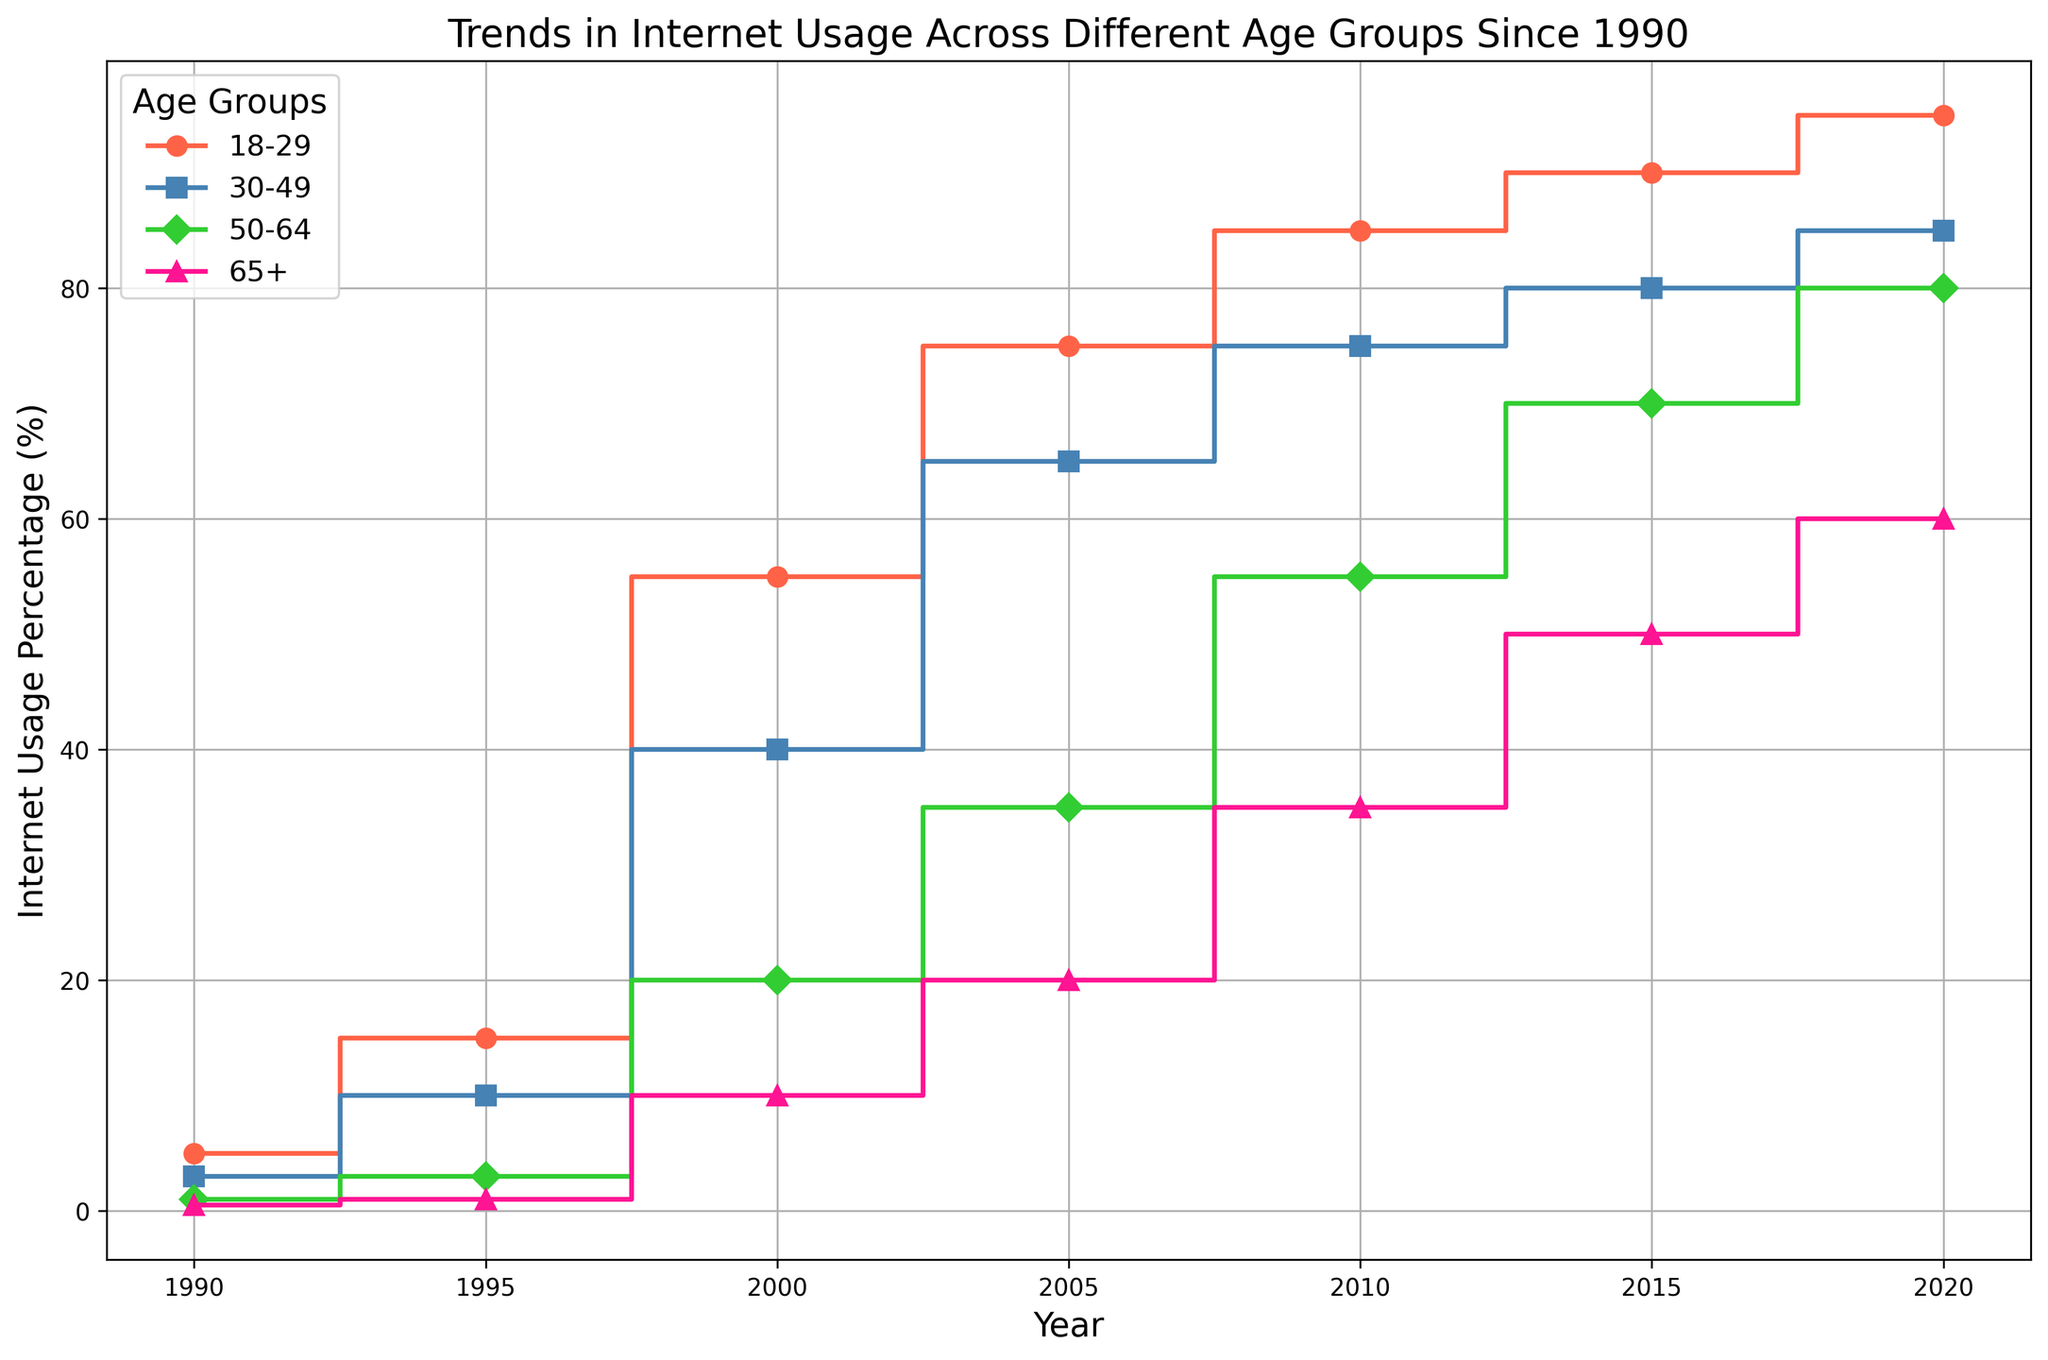Which age group had the highest internet usage percentage in 2000? In 2000, we can see the step-like increases for different groups. The highest internet usage percentage is the tallest step. Inspect the plot to identify that the 18-29 age group has the highest step.
Answer: 18-29 What is the difference in internet usage percentage between the 18-29 age group and the 65+ age group in 2010? Locate the steps for 2010 and identify the heights for both the 18-29 and 65+ age groups. The percentage for 18-29 is 85%, and for 65+ is 35%. Subtract the smaller percentage from the larger one: 85% - 35% = 50%.
Answer: 50% How did internet usage for the 50-64 age group change between 1990 and 2020? Note the steps for the 50-64 age group in 1990 and 2020. The percentage in 1990 is 1% and in 2020 it's 80%. Subtract the 1990 value from the 2020 value: 80% - 1% = 79%.
Answer: Increased by 79% What is the average internet usage percentage of all age groups in 2005? Identify the steps corresponding to 2005 and note the percentages: 75% (18-29), 65% (30-49), 35% (50-64), and 20% (65+). Calculate the average: (75% + 65% + 35% + 20%)/4 = 195%/4 = 48.75%.
Answer: 48.75% Which age group showed the greatest percentage increase in internet usage from 1990 to 2020? Compare percentage changes for each age group: 18-29 (5% to 95% = 90%), 30-49 (3% to 85% = 82%), 50-64 (1% to 80% = 79%), 65+ (0.5% to 60% = 59.5%). The group with the largest difference is the 18-29 age group with a 90% increase.
Answer: 18-29 Between which years did the 30-49 age group see the largest increase in internet usage? Examine the steps for the 30-49 age group for each pair of consecutive years. The largest increase is between 2000 (40%) and 2005 (65%), which is 25%. Verify other pairs to confirm this is the largest.
Answer: 2000 to 2005 Which age group had the smallest percentage difference in internet usage between 1995 and 2015? Identify the steps for each age group in 1995 and 2015, then calculate differences: 18-29 (90%-15% = 75%), 30-49 (80%-10% = 70%), 50-64 (70%-3% = 67%), 65+ (50%-1% = 49%). The smallest difference is for the 65+ age group.
Answer: 65+ How does the internet usage trend for the 65+ age group compare to that for the 18-29 age group? Look at the trend lines for both groups. The 18-29 group shows a rapid increase from the beginning, while the 65+ group starts very low and shows a steadier but significant increase over time. Despite this, the 18-29 group consistently has the highest usage.
Answer: More rapid for 18-29, steeper increase for 65+ What is the combined internet usage percentage for the 30-49 and 50-64 age groups in 2020? Find the steps for the 30-49 and 50-64 age groups for 2020: 85% and 80%. Add these together: 85% + 80% = 165%.
Answer: 165% In which year did the 50-64 age group first surpass 50% internet usage? Follow the steps representing the 50-64 age group. The percentage surpasses 50% for the first time between 2005 (35%) and 2010 (55%). Thus, it first surpasses in 2010.
Answer: 2010 